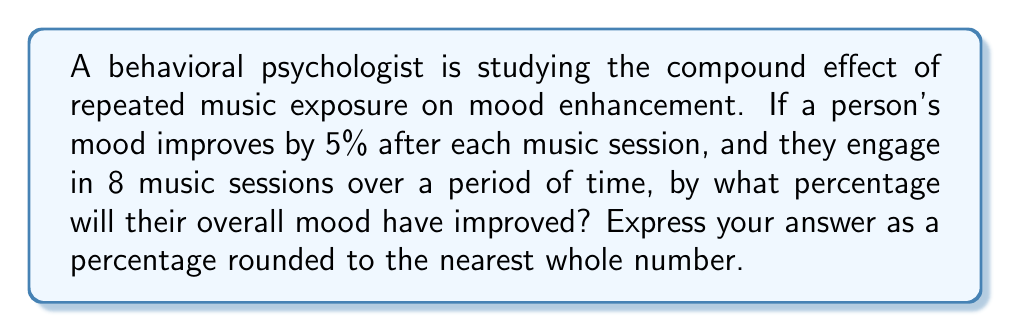Can you answer this question? To solve this problem, we can use the compound interest formula, which is analogous to the compound effect of repeated music exposure:

1) The base formula is: $A = P(1 + r)^n$

   Where:
   $A$ = Final amount
   $P$ = Initial amount (in this case, 1 or 100%)
   $r$ = Rate of increase per session (5% or 0.05)
   $n$ = Number of sessions (8)

2) Plugging in our values:
   $A = 1(1 + 0.05)^8$

3) Calculate:
   $A = (1.05)^8 = 1.4775$

4) To convert this to a percentage increase:
   Percentage increase = $(A - 1) * 100\%$
   $= (1.4775 - 1) * 100\% = 0.4775 * 100\% = 47.75\%$

5) Rounding to the nearest whole number:
   $47.75\% \approx 48\%$

Therefore, after 8 music sessions, the person's mood will have improved by approximately 48%.
Answer: 48% 